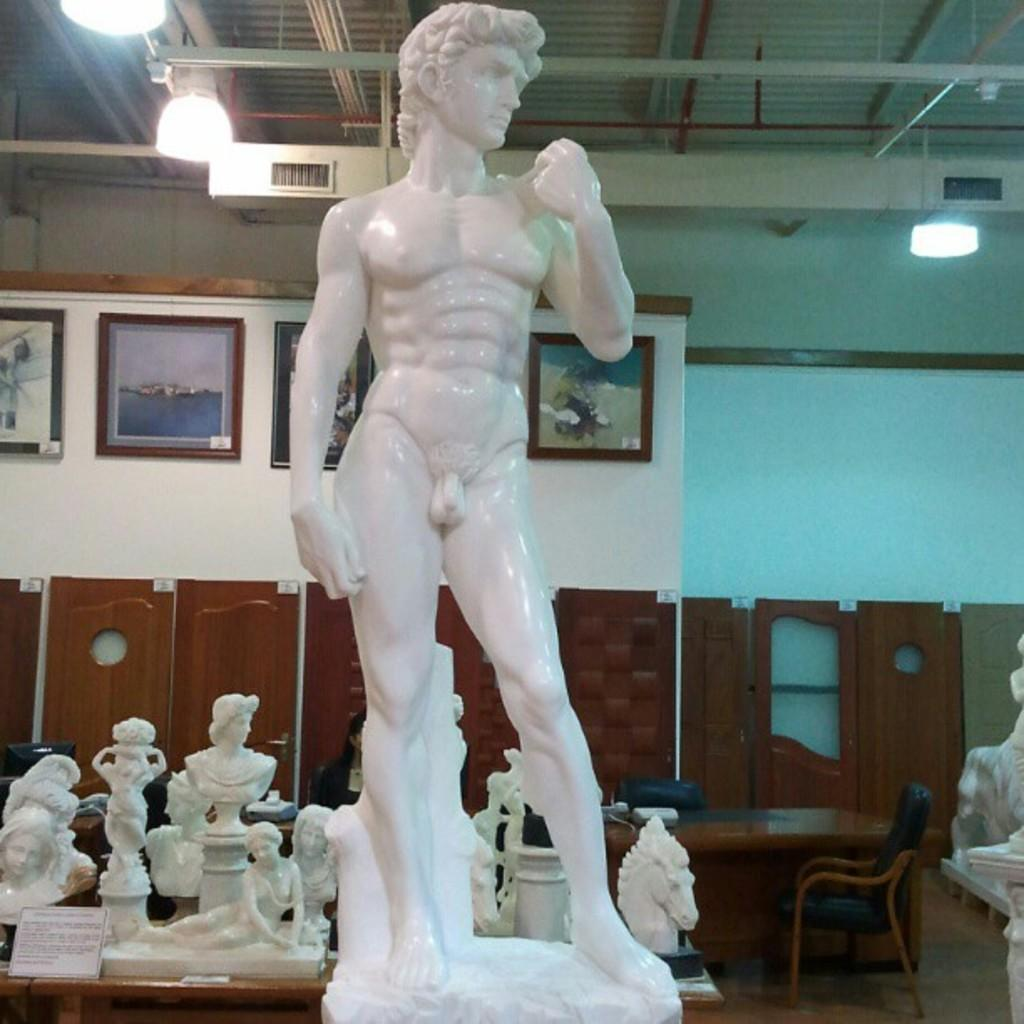What type of art is present in the image? There are many sculptures in the image. What can be seen on the wall in the image? There are photo frames on the wall. What type of furniture is visible in the image? There is a chair in the image. What type of lighting is present in the image? There are lights on the ceiling. What type of vessel can be seen sailing in the harbor in the image? There is no vessel or harbor present in the image; it features sculptures, photo frames, a chair, and lights on the ceiling. 